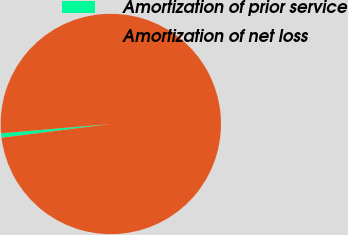Convert chart to OTSL. <chart><loc_0><loc_0><loc_500><loc_500><pie_chart><fcel>Amortization of prior service<fcel>Amortization of net loss<nl><fcel>0.64%<fcel>99.36%<nl></chart> 